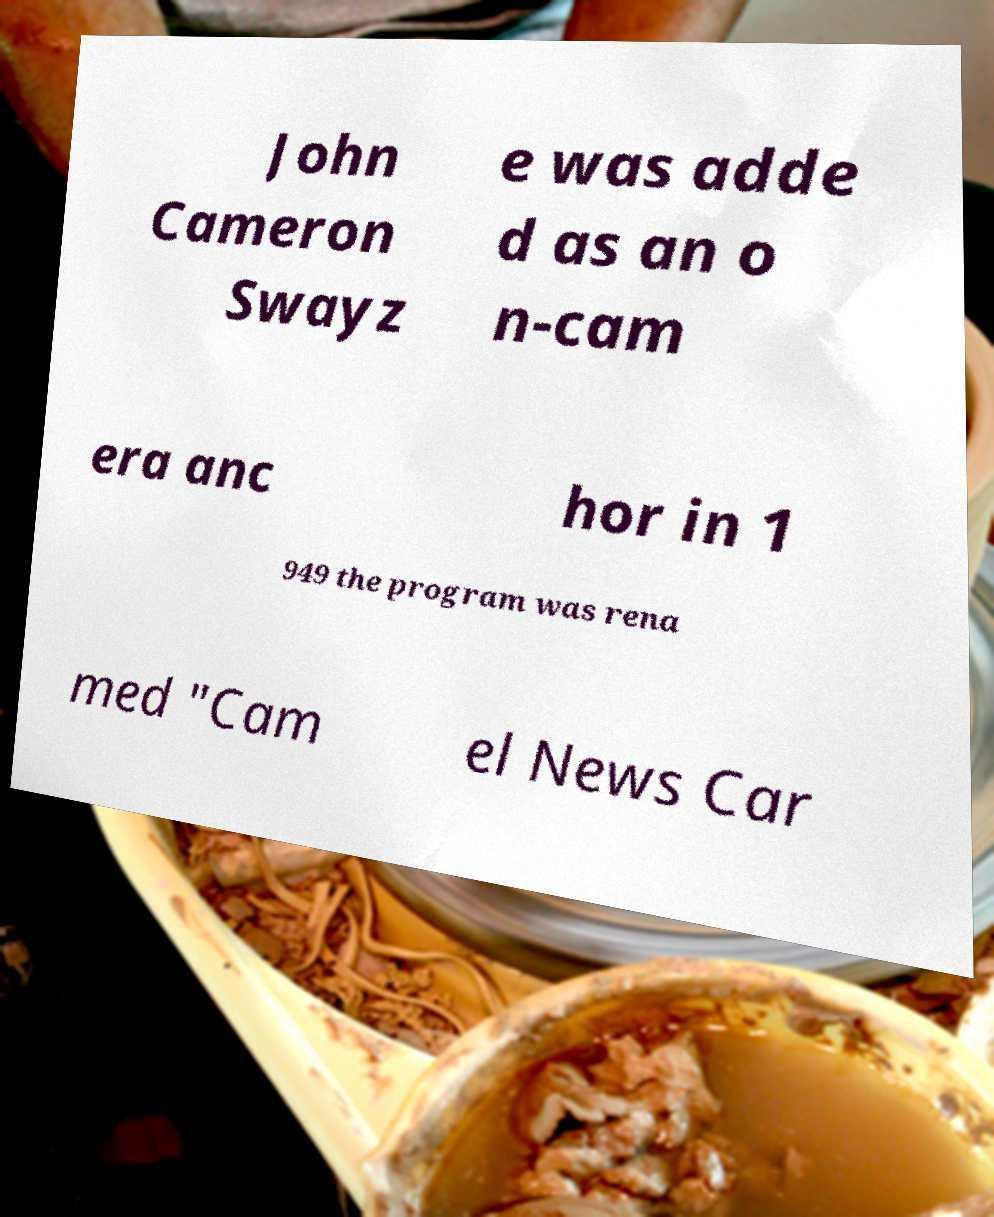There's text embedded in this image that I need extracted. Can you transcribe it verbatim? John Cameron Swayz e was adde d as an o n-cam era anc hor in 1 949 the program was rena med "Cam el News Car 